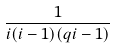<formula> <loc_0><loc_0><loc_500><loc_500>\frac { 1 } { i ( i - 1 ) ( q i - 1 ) }</formula> 